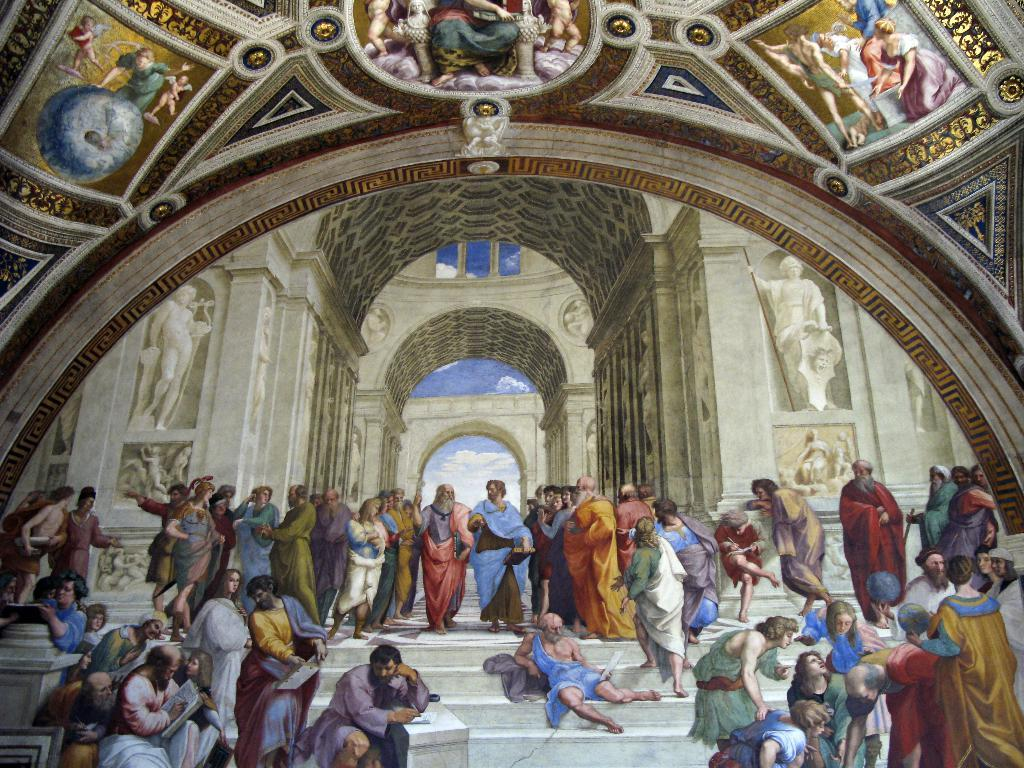What is depicted in the painting in the image? There is a painting of a group of people in the image. What other art forms can be seen in the image? There are sculptures in the background of the image. What architectural feature is visible at the top of the image? There is a roof visible at the top of the image. Where is the faucet located in the image? There is no faucet present in the image. What type of school is depicted in the painting? The painting does not depict a school; it features a group of people. 